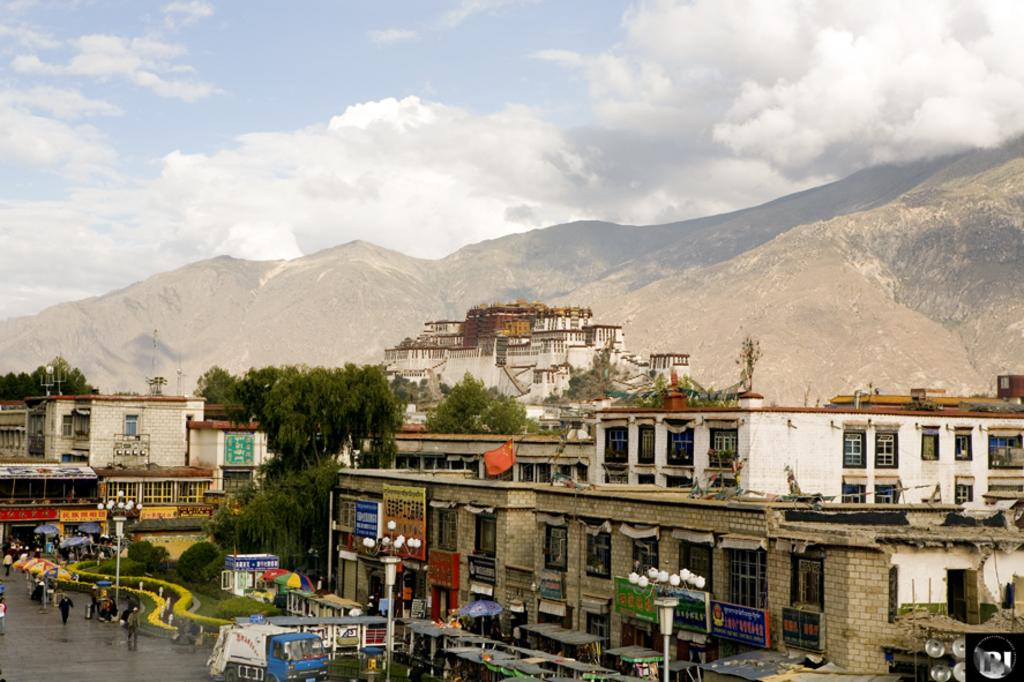What type of structures can be seen in the image? There are buildings in the image. What natural elements are present in the image? There are trees and mountains in the image. What man-made objects can be seen in the image? There are light poles, stores, vehicles, and tents in the image. Who or what can be seen in the image? There are people in the image. What architectural features are visible in the buildings? There are glass windows in the image. What additional objects can be seen in the image? There are different boards in the image. Can you see a tiger walking around in the image? No, there is no tiger present in the image. What type of record can be seen in the image? There is no record present in the image. 